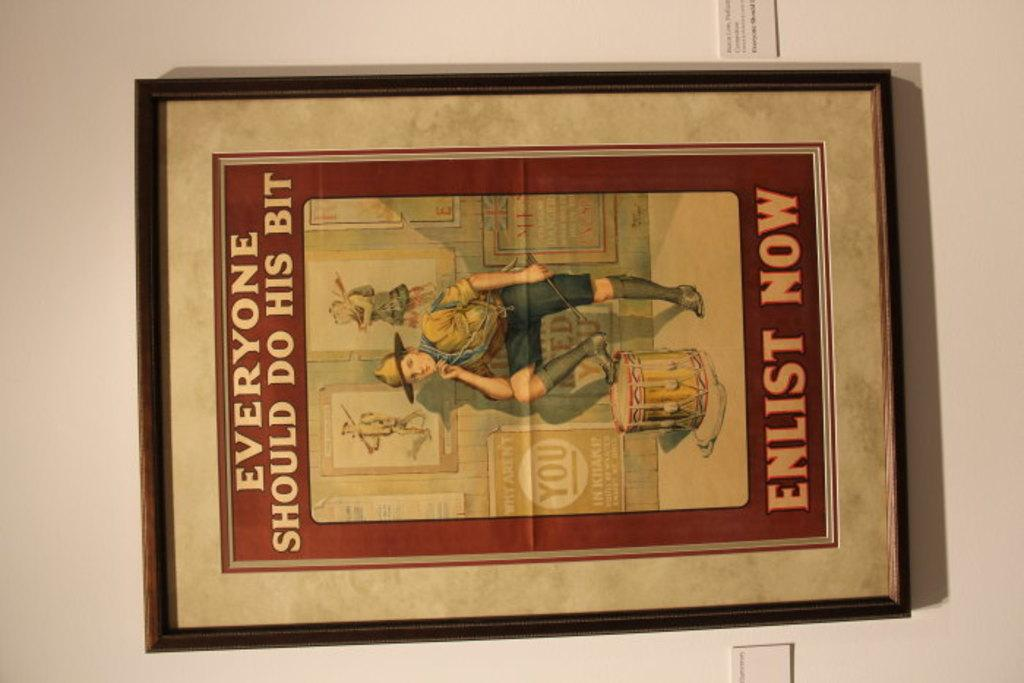<image>
Summarize the visual content of the image. Picture of everyone should do his bit enlist now 